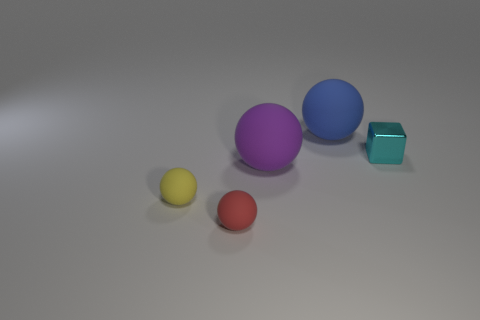Add 2 red cylinders. How many objects exist? 7 Subtract all blocks. How many objects are left? 4 Add 2 matte objects. How many matte objects exist? 6 Subtract 0 gray balls. How many objects are left? 5 Subtract all small cyan objects. Subtract all big blue objects. How many objects are left? 3 Add 4 red rubber things. How many red rubber things are left? 5 